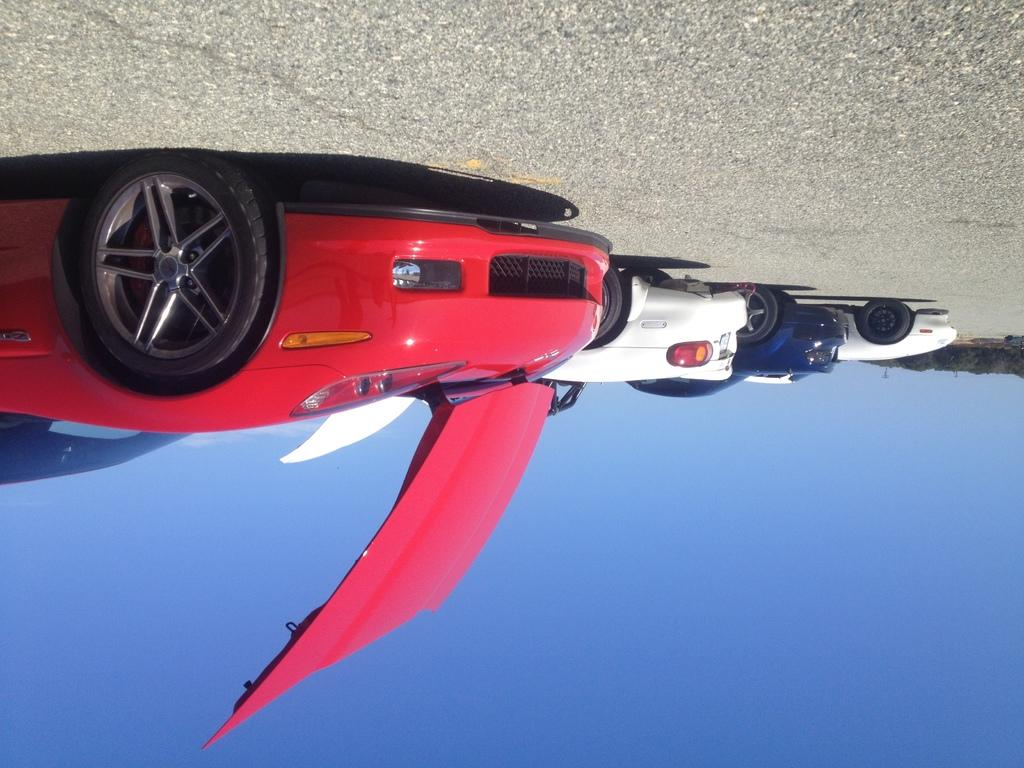What is the main subject of the image? The main subject of the image is a road. What can be seen on the road? There are different cars on the road. What type of natural scenery is visible in the background? There are trees visible in the background. What is visible at the top of the image? The sky is visible at the top of the image. What type of cracker is being used to calculate arithmetic problems in the image? There is no cracker or arithmetic problem present in the image; it depicts a road with cars and trees in the background. 